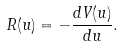<formula> <loc_0><loc_0><loc_500><loc_500>R ( u ) = - \frac { d V ( u ) } { d u } .</formula> 